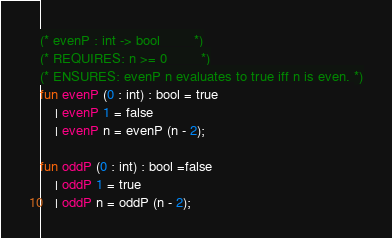<code> <loc_0><loc_0><loc_500><loc_500><_SML_>(* evenP : int -> bool 		*)
(* REQUIRES: n >= 0 		*)
(* ENSURES: evenP n evaluates to true iff n is even. *)
fun evenP (0 : int) : bool = true
	| evenP 1 = false
	| evenP n = evenP (n - 2);

fun oddP (0 : int) : bool =false
	| oddP 1 = true
	| oddP n = oddP (n - 2);
</code> 